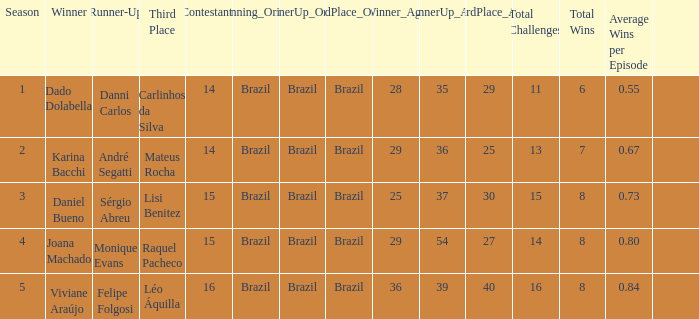Who was the winner when Mateus Rocha finished in 3rd place?  Karina Bacchi. 